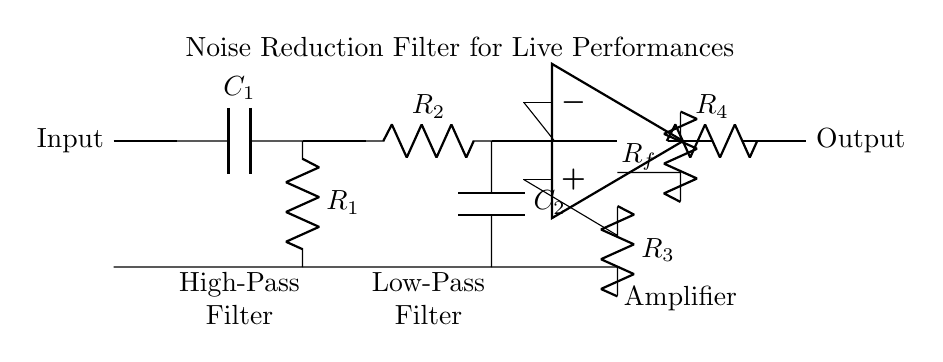What type of filter is depicted in this circuit? The circuit contains both a high-pass filter and a low-pass filter, which are combined to serve as a noise reduction filter. The high-pass filter blocks low-frequency noise while the low-pass filter blocks high-frequency noise, allowing only a specific range of frequencies to pass through.
Answer: Noise reduction filter What are the components used in the high-pass filter? The high-pass filter in this circuit contains a capacitor labeled C1 and a resistor labeled R1. The capacitor allows high-frequency signals to pass while blocking low frequencies, and the resistor helps establish the cutoff frequency.
Answer: C1 and R1 How many resistors are present in the entire circuit? By examining the diagram, you can see four resistors: R1, R2, R3, and R4, which are used in the filtering and amplification stages of the circuit.
Answer: Four What is the purpose of the amplifier in this circuit? The amplifier boosts the signal after it passes through the filters. It takes the filtered audio signal and increases its amplitude for a stronger output, making it suitable for live performance applications where sound clarity and volume are crucial.
Answer: To boost the signal What happens to low-frequency signals in this circuit? Low-frequency signals are blocked by the high-pass filter which comprises the capacitor and resistor. This allows higher frequency signals to pass through while attenuating frequencies below the cutoff frequency set by the components in that filter.
Answer: Blocked Which component connects the output to the final resistor? The output is connected to the final resistor, R4, via the amplifier. The amplifier sends its output to R4, which further processes the signal before it reaches the output.
Answer: R4 What is the role of the low-pass filter in this circuit? The low-pass filter allows low-frequency signals to pass while blocking high-frequency signals, which helps to eliminate unwanted noise or interference from higher frequency range, ensuring a clearer sound during live performances.
Answer: To remove high-frequency noise 